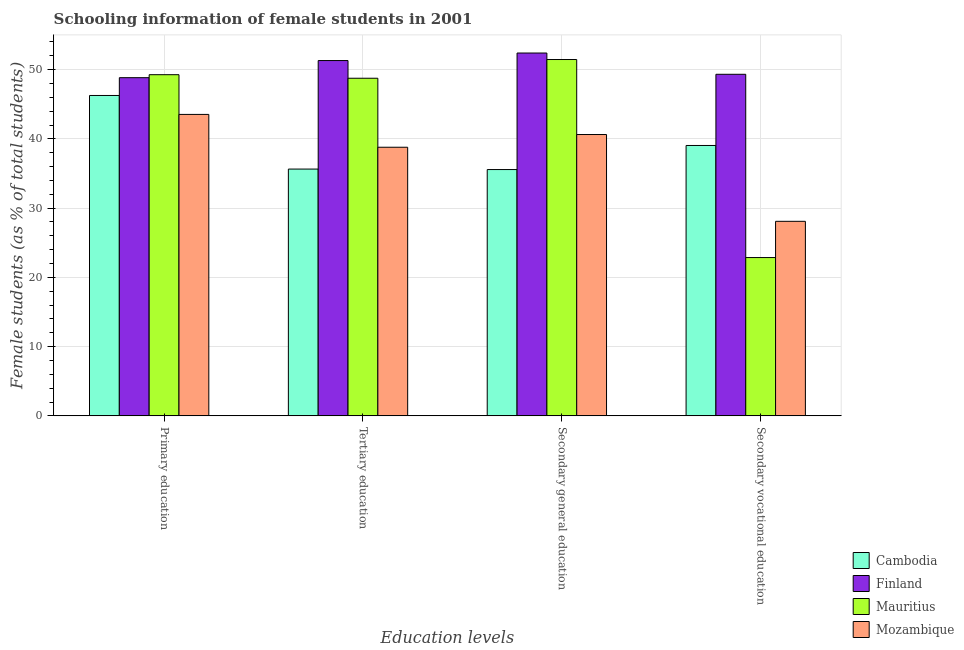How many different coloured bars are there?
Your answer should be very brief. 4. How many groups of bars are there?
Offer a very short reply. 4. Are the number of bars per tick equal to the number of legend labels?
Provide a succinct answer. Yes. Are the number of bars on each tick of the X-axis equal?
Give a very brief answer. Yes. How many bars are there on the 2nd tick from the left?
Your answer should be very brief. 4. How many bars are there on the 4th tick from the right?
Keep it short and to the point. 4. What is the label of the 4th group of bars from the left?
Keep it short and to the point. Secondary vocational education. What is the percentage of female students in secondary vocational education in Finland?
Give a very brief answer. 49.33. Across all countries, what is the maximum percentage of female students in secondary education?
Make the answer very short. 52.41. Across all countries, what is the minimum percentage of female students in tertiary education?
Make the answer very short. 35.64. In which country was the percentage of female students in primary education maximum?
Offer a very short reply. Mauritius. In which country was the percentage of female students in primary education minimum?
Provide a succinct answer. Mozambique. What is the total percentage of female students in secondary education in the graph?
Give a very brief answer. 180.08. What is the difference between the percentage of female students in primary education in Mauritius and that in Finland?
Offer a terse response. 0.43. What is the difference between the percentage of female students in secondary vocational education in Finland and the percentage of female students in primary education in Mauritius?
Your response must be concise. 0.06. What is the average percentage of female students in secondary vocational education per country?
Offer a terse response. 34.84. What is the difference between the percentage of female students in tertiary education and percentage of female students in secondary vocational education in Cambodia?
Your answer should be very brief. -3.41. What is the ratio of the percentage of female students in secondary vocational education in Mozambique to that in Cambodia?
Keep it short and to the point. 0.72. Is the difference between the percentage of female students in primary education in Finland and Mozambique greater than the difference between the percentage of female students in tertiary education in Finland and Mozambique?
Your answer should be very brief. No. What is the difference between the highest and the second highest percentage of female students in secondary vocational education?
Your answer should be very brief. 10.28. What is the difference between the highest and the lowest percentage of female students in primary education?
Give a very brief answer. 5.74. In how many countries, is the percentage of female students in secondary education greater than the average percentage of female students in secondary education taken over all countries?
Keep it short and to the point. 2. Is the sum of the percentage of female students in secondary vocational education in Finland and Mozambique greater than the maximum percentage of female students in primary education across all countries?
Offer a terse response. Yes. What does the 4th bar from the left in Tertiary education represents?
Offer a very short reply. Mozambique. What does the 4th bar from the right in Secondary general education represents?
Ensure brevity in your answer.  Cambodia. Are all the bars in the graph horizontal?
Keep it short and to the point. No. What is the difference between two consecutive major ticks on the Y-axis?
Offer a terse response. 10. Are the values on the major ticks of Y-axis written in scientific E-notation?
Provide a succinct answer. No. Does the graph contain any zero values?
Your answer should be compact. No. Does the graph contain grids?
Provide a succinct answer. Yes. How many legend labels are there?
Your response must be concise. 4. How are the legend labels stacked?
Offer a very short reply. Vertical. What is the title of the graph?
Your answer should be compact. Schooling information of female students in 2001. Does "Chad" appear as one of the legend labels in the graph?
Your answer should be compact. No. What is the label or title of the X-axis?
Your response must be concise. Education levels. What is the label or title of the Y-axis?
Provide a succinct answer. Female students (as % of total students). What is the Female students (as % of total students) of Cambodia in Primary education?
Offer a terse response. 46.27. What is the Female students (as % of total students) in Finland in Primary education?
Make the answer very short. 48.84. What is the Female students (as % of total students) in Mauritius in Primary education?
Provide a succinct answer. 49.28. What is the Female students (as % of total students) of Mozambique in Primary education?
Make the answer very short. 43.54. What is the Female students (as % of total students) in Cambodia in Tertiary education?
Make the answer very short. 35.64. What is the Female students (as % of total students) in Finland in Tertiary education?
Offer a terse response. 51.32. What is the Female students (as % of total students) of Mauritius in Tertiary education?
Provide a succinct answer. 48.76. What is the Female students (as % of total students) in Mozambique in Tertiary education?
Offer a very short reply. 38.8. What is the Female students (as % of total students) of Cambodia in Secondary general education?
Your response must be concise. 35.57. What is the Female students (as % of total students) in Finland in Secondary general education?
Offer a terse response. 52.41. What is the Female students (as % of total students) in Mauritius in Secondary general education?
Provide a short and direct response. 51.47. What is the Female students (as % of total students) in Mozambique in Secondary general education?
Offer a terse response. 40.63. What is the Female students (as % of total students) of Cambodia in Secondary vocational education?
Provide a short and direct response. 39.05. What is the Female students (as % of total students) in Finland in Secondary vocational education?
Ensure brevity in your answer.  49.33. What is the Female students (as % of total students) in Mauritius in Secondary vocational education?
Your answer should be very brief. 22.86. What is the Female students (as % of total students) in Mozambique in Secondary vocational education?
Your response must be concise. 28.1. Across all Education levels, what is the maximum Female students (as % of total students) in Cambodia?
Your response must be concise. 46.27. Across all Education levels, what is the maximum Female students (as % of total students) of Finland?
Your answer should be compact. 52.41. Across all Education levels, what is the maximum Female students (as % of total students) of Mauritius?
Ensure brevity in your answer.  51.47. Across all Education levels, what is the maximum Female students (as % of total students) of Mozambique?
Ensure brevity in your answer.  43.54. Across all Education levels, what is the minimum Female students (as % of total students) of Cambodia?
Provide a short and direct response. 35.57. Across all Education levels, what is the minimum Female students (as % of total students) of Finland?
Keep it short and to the point. 48.84. Across all Education levels, what is the minimum Female students (as % of total students) in Mauritius?
Give a very brief answer. 22.86. Across all Education levels, what is the minimum Female students (as % of total students) in Mozambique?
Offer a terse response. 28.1. What is the total Female students (as % of total students) of Cambodia in the graph?
Offer a very short reply. 156.54. What is the total Female students (as % of total students) in Finland in the graph?
Keep it short and to the point. 201.9. What is the total Female students (as % of total students) in Mauritius in the graph?
Keep it short and to the point. 172.37. What is the total Female students (as % of total students) in Mozambique in the graph?
Make the answer very short. 151.07. What is the difference between the Female students (as % of total students) of Cambodia in Primary education and that in Tertiary education?
Your response must be concise. 10.63. What is the difference between the Female students (as % of total students) of Finland in Primary education and that in Tertiary education?
Your answer should be very brief. -2.47. What is the difference between the Female students (as % of total students) of Mauritius in Primary education and that in Tertiary education?
Provide a short and direct response. 0.51. What is the difference between the Female students (as % of total students) in Mozambique in Primary education and that in Tertiary education?
Your answer should be very brief. 4.74. What is the difference between the Female students (as % of total students) in Cambodia in Primary education and that in Secondary general education?
Offer a very short reply. 10.7. What is the difference between the Female students (as % of total students) of Finland in Primary education and that in Secondary general education?
Offer a terse response. -3.56. What is the difference between the Female students (as % of total students) in Mauritius in Primary education and that in Secondary general education?
Keep it short and to the point. -2.19. What is the difference between the Female students (as % of total students) of Mozambique in Primary education and that in Secondary general education?
Give a very brief answer. 2.91. What is the difference between the Female students (as % of total students) in Cambodia in Primary education and that in Secondary vocational education?
Provide a succinct answer. 7.22. What is the difference between the Female students (as % of total students) of Finland in Primary education and that in Secondary vocational education?
Offer a terse response. -0.49. What is the difference between the Female students (as % of total students) of Mauritius in Primary education and that in Secondary vocational education?
Offer a terse response. 26.41. What is the difference between the Female students (as % of total students) in Mozambique in Primary education and that in Secondary vocational education?
Provide a short and direct response. 15.44. What is the difference between the Female students (as % of total students) in Cambodia in Tertiary education and that in Secondary general education?
Keep it short and to the point. 0.07. What is the difference between the Female students (as % of total students) of Finland in Tertiary education and that in Secondary general education?
Keep it short and to the point. -1.09. What is the difference between the Female students (as % of total students) in Mauritius in Tertiary education and that in Secondary general education?
Ensure brevity in your answer.  -2.7. What is the difference between the Female students (as % of total students) of Mozambique in Tertiary education and that in Secondary general education?
Ensure brevity in your answer.  -1.84. What is the difference between the Female students (as % of total students) in Cambodia in Tertiary education and that in Secondary vocational education?
Provide a short and direct response. -3.41. What is the difference between the Female students (as % of total students) of Finland in Tertiary education and that in Secondary vocational education?
Make the answer very short. 1.98. What is the difference between the Female students (as % of total students) in Mauritius in Tertiary education and that in Secondary vocational education?
Your answer should be compact. 25.9. What is the difference between the Female students (as % of total students) in Mozambique in Tertiary education and that in Secondary vocational education?
Ensure brevity in your answer.  10.7. What is the difference between the Female students (as % of total students) of Cambodia in Secondary general education and that in Secondary vocational education?
Offer a terse response. -3.48. What is the difference between the Female students (as % of total students) of Finland in Secondary general education and that in Secondary vocational education?
Make the answer very short. 3.07. What is the difference between the Female students (as % of total students) of Mauritius in Secondary general education and that in Secondary vocational education?
Your answer should be very brief. 28.6. What is the difference between the Female students (as % of total students) in Mozambique in Secondary general education and that in Secondary vocational education?
Provide a short and direct response. 12.53. What is the difference between the Female students (as % of total students) of Cambodia in Primary education and the Female students (as % of total students) of Finland in Tertiary education?
Your answer should be very brief. -5.04. What is the difference between the Female students (as % of total students) of Cambodia in Primary education and the Female students (as % of total students) of Mauritius in Tertiary education?
Keep it short and to the point. -2.49. What is the difference between the Female students (as % of total students) of Cambodia in Primary education and the Female students (as % of total students) of Mozambique in Tertiary education?
Ensure brevity in your answer.  7.48. What is the difference between the Female students (as % of total students) in Finland in Primary education and the Female students (as % of total students) in Mauritius in Tertiary education?
Provide a short and direct response. 0.08. What is the difference between the Female students (as % of total students) in Finland in Primary education and the Female students (as % of total students) in Mozambique in Tertiary education?
Provide a short and direct response. 10.05. What is the difference between the Female students (as % of total students) in Mauritius in Primary education and the Female students (as % of total students) in Mozambique in Tertiary education?
Keep it short and to the point. 10.48. What is the difference between the Female students (as % of total students) of Cambodia in Primary education and the Female students (as % of total students) of Finland in Secondary general education?
Provide a short and direct response. -6.13. What is the difference between the Female students (as % of total students) in Cambodia in Primary education and the Female students (as % of total students) in Mauritius in Secondary general education?
Make the answer very short. -5.19. What is the difference between the Female students (as % of total students) in Cambodia in Primary education and the Female students (as % of total students) in Mozambique in Secondary general education?
Make the answer very short. 5.64. What is the difference between the Female students (as % of total students) in Finland in Primary education and the Female students (as % of total students) in Mauritius in Secondary general education?
Offer a terse response. -2.62. What is the difference between the Female students (as % of total students) in Finland in Primary education and the Female students (as % of total students) in Mozambique in Secondary general education?
Provide a succinct answer. 8.21. What is the difference between the Female students (as % of total students) of Mauritius in Primary education and the Female students (as % of total students) of Mozambique in Secondary general education?
Make the answer very short. 8.64. What is the difference between the Female students (as % of total students) of Cambodia in Primary education and the Female students (as % of total students) of Finland in Secondary vocational education?
Offer a very short reply. -3.06. What is the difference between the Female students (as % of total students) of Cambodia in Primary education and the Female students (as % of total students) of Mauritius in Secondary vocational education?
Offer a terse response. 23.41. What is the difference between the Female students (as % of total students) of Cambodia in Primary education and the Female students (as % of total students) of Mozambique in Secondary vocational education?
Offer a terse response. 18.17. What is the difference between the Female students (as % of total students) of Finland in Primary education and the Female students (as % of total students) of Mauritius in Secondary vocational education?
Give a very brief answer. 25.98. What is the difference between the Female students (as % of total students) of Finland in Primary education and the Female students (as % of total students) of Mozambique in Secondary vocational education?
Provide a short and direct response. 20.75. What is the difference between the Female students (as % of total students) of Mauritius in Primary education and the Female students (as % of total students) of Mozambique in Secondary vocational education?
Your response must be concise. 21.18. What is the difference between the Female students (as % of total students) of Cambodia in Tertiary education and the Female students (as % of total students) of Finland in Secondary general education?
Give a very brief answer. -16.76. What is the difference between the Female students (as % of total students) of Cambodia in Tertiary education and the Female students (as % of total students) of Mauritius in Secondary general education?
Ensure brevity in your answer.  -15.82. What is the difference between the Female students (as % of total students) of Cambodia in Tertiary education and the Female students (as % of total students) of Mozambique in Secondary general education?
Your answer should be compact. -4.99. What is the difference between the Female students (as % of total students) of Finland in Tertiary education and the Female students (as % of total students) of Mauritius in Secondary general education?
Keep it short and to the point. -0.15. What is the difference between the Female students (as % of total students) of Finland in Tertiary education and the Female students (as % of total students) of Mozambique in Secondary general education?
Offer a very short reply. 10.68. What is the difference between the Female students (as % of total students) of Mauritius in Tertiary education and the Female students (as % of total students) of Mozambique in Secondary general education?
Your response must be concise. 8.13. What is the difference between the Female students (as % of total students) in Cambodia in Tertiary education and the Female students (as % of total students) in Finland in Secondary vocational education?
Make the answer very short. -13.69. What is the difference between the Female students (as % of total students) in Cambodia in Tertiary education and the Female students (as % of total students) in Mauritius in Secondary vocational education?
Ensure brevity in your answer.  12.78. What is the difference between the Female students (as % of total students) in Cambodia in Tertiary education and the Female students (as % of total students) in Mozambique in Secondary vocational education?
Offer a terse response. 7.54. What is the difference between the Female students (as % of total students) in Finland in Tertiary education and the Female students (as % of total students) in Mauritius in Secondary vocational education?
Keep it short and to the point. 28.45. What is the difference between the Female students (as % of total students) in Finland in Tertiary education and the Female students (as % of total students) in Mozambique in Secondary vocational education?
Your answer should be very brief. 23.22. What is the difference between the Female students (as % of total students) in Mauritius in Tertiary education and the Female students (as % of total students) in Mozambique in Secondary vocational education?
Make the answer very short. 20.66. What is the difference between the Female students (as % of total students) in Cambodia in Secondary general education and the Female students (as % of total students) in Finland in Secondary vocational education?
Give a very brief answer. -13.76. What is the difference between the Female students (as % of total students) in Cambodia in Secondary general education and the Female students (as % of total students) in Mauritius in Secondary vocational education?
Offer a terse response. 12.71. What is the difference between the Female students (as % of total students) in Cambodia in Secondary general education and the Female students (as % of total students) in Mozambique in Secondary vocational education?
Provide a succinct answer. 7.48. What is the difference between the Female students (as % of total students) of Finland in Secondary general education and the Female students (as % of total students) of Mauritius in Secondary vocational education?
Offer a very short reply. 29.54. What is the difference between the Female students (as % of total students) in Finland in Secondary general education and the Female students (as % of total students) in Mozambique in Secondary vocational education?
Offer a very short reply. 24.31. What is the difference between the Female students (as % of total students) of Mauritius in Secondary general education and the Female students (as % of total students) of Mozambique in Secondary vocational education?
Provide a succinct answer. 23.37. What is the average Female students (as % of total students) in Cambodia per Education levels?
Give a very brief answer. 39.14. What is the average Female students (as % of total students) of Finland per Education levels?
Make the answer very short. 50.47. What is the average Female students (as % of total students) in Mauritius per Education levels?
Offer a very short reply. 43.09. What is the average Female students (as % of total students) in Mozambique per Education levels?
Your response must be concise. 37.77. What is the difference between the Female students (as % of total students) of Cambodia and Female students (as % of total students) of Finland in Primary education?
Provide a short and direct response. -2.57. What is the difference between the Female students (as % of total students) in Cambodia and Female students (as % of total students) in Mauritius in Primary education?
Keep it short and to the point. -3. What is the difference between the Female students (as % of total students) in Cambodia and Female students (as % of total students) in Mozambique in Primary education?
Your answer should be compact. 2.73. What is the difference between the Female students (as % of total students) of Finland and Female students (as % of total students) of Mauritius in Primary education?
Provide a succinct answer. -0.43. What is the difference between the Female students (as % of total students) of Finland and Female students (as % of total students) of Mozambique in Primary education?
Provide a short and direct response. 5.31. What is the difference between the Female students (as % of total students) in Mauritius and Female students (as % of total students) in Mozambique in Primary education?
Your response must be concise. 5.74. What is the difference between the Female students (as % of total students) of Cambodia and Female students (as % of total students) of Finland in Tertiary education?
Provide a succinct answer. -15.67. What is the difference between the Female students (as % of total students) of Cambodia and Female students (as % of total students) of Mauritius in Tertiary education?
Provide a short and direct response. -13.12. What is the difference between the Female students (as % of total students) in Cambodia and Female students (as % of total students) in Mozambique in Tertiary education?
Your response must be concise. -3.15. What is the difference between the Female students (as % of total students) in Finland and Female students (as % of total students) in Mauritius in Tertiary education?
Ensure brevity in your answer.  2.56. What is the difference between the Female students (as % of total students) in Finland and Female students (as % of total students) in Mozambique in Tertiary education?
Your response must be concise. 12.52. What is the difference between the Female students (as % of total students) in Mauritius and Female students (as % of total students) in Mozambique in Tertiary education?
Your answer should be very brief. 9.96. What is the difference between the Female students (as % of total students) in Cambodia and Female students (as % of total students) in Finland in Secondary general education?
Your response must be concise. -16.83. What is the difference between the Female students (as % of total students) of Cambodia and Female students (as % of total students) of Mauritius in Secondary general education?
Make the answer very short. -15.89. What is the difference between the Female students (as % of total students) of Cambodia and Female students (as % of total students) of Mozambique in Secondary general education?
Your answer should be very brief. -5.06. What is the difference between the Female students (as % of total students) in Finland and Female students (as % of total students) in Mauritius in Secondary general education?
Keep it short and to the point. 0.94. What is the difference between the Female students (as % of total students) in Finland and Female students (as % of total students) in Mozambique in Secondary general education?
Make the answer very short. 11.77. What is the difference between the Female students (as % of total students) of Mauritius and Female students (as % of total students) of Mozambique in Secondary general education?
Your answer should be compact. 10.83. What is the difference between the Female students (as % of total students) of Cambodia and Female students (as % of total students) of Finland in Secondary vocational education?
Give a very brief answer. -10.28. What is the difference between the Female students (as % of total students) of Cambodia and Female students (as % of total students) of Mauritius in Secondary vocational education?
Make the answer very short. 16.19. What is the difference between the Female students (as % of total students) of Cambodia and Female students (as % of total students) of Mozambique in Secondary vocational education?
Your answer should be very brief. 10.95. What is the difference between the Female students (as % of total students) of Finland and Female students (as % of total students) of Mauritius in Secondary vocational education?
Your answer should be compact. 26.47. What is the difference between the Female students (as % of total students) of Finland and Female students (as % of total students) of Mozambique in Secondary vocational education?
Offer a terse response. 21.23. What is the difference between the Female students (as % of total students) of Mauritius and Female students (as % of total students) of Mozambique in Secondary vocational education?
Your response must be concise. -5.23. What is the ratio of the Female students (as % of total students) of Cambodia in Primary education to that in Tertiary education?
Ensure brevity in your answer.  1.3. What is the ratio of the Female students (as % of total students) of Finland in Primary education to that in Tertiary education?
Your answer should be very brief. 0.95. What is the ratio of the Female students (as % of total students) of Mauritius in Primary education to that in Tertiary education?
Ensure brevity in your answer.  1.01. What is the ratio of the Female students (as % of total students) in Mozambique in Primary education to that in Tertiary education?
Offer a very short reply. 1.12. What is the ratio of the Female students (as % of total students) in Cambodia in Primary education to that in Secondary general education?
Your answer should be very brief. 1.3. What is the ratio of the Female students (as % of total students) in Finland in Primary education to that in Secondary general education?
Your response must be concise. 0.93. What is the ratio of the Female students (as % of total students) of Mauritius in Primary education to that in Secondary general education?
Your answer should be compact. 0.96. What is the ratio of the Female students (as % of total students) in Mozambique in Primary education to that in Secondary general education?
Make the answer very short. 1.07. What is the ratio of the Female students (as % of total students) of Cambodia in Primary education to that in Secondary vocational education?
Provide a short and direct response. 1.18. What is the ratio of the Female students (as % of total students) of Mauritius in Primary education to that in Secondary vocational education?
Make the answer very short. 2.16. What is the ratio of the Female students (as % of total students) in Mozambique in Primary education to that in Secondary vocational education?
Ensure brevity in your answer.  1.55. What is the ratio of the Female students (as % of total students) of Cambodia in Tertiary education to that in Secondary general education?
Your answer should be very brief. 1. What is the ratio of the Female students (as % of total students) in Finland in Tertiary education to that in Secondary general education?
Ensure brevity in your answer.  0.98. What is the ratio of the Female students (as % of total students) of Mauritius in Tertiary education to that in Secondary general education?
Keep it short and to the point. 0.95. What is the ratio of the Female students (as % of total students) of Mozambique in Tertiary education to that in Secondary general education?
Offer a very short reply. 0.95. What is the ratio of the Female students (as % of total students) in Cambodia in Tertiary education to that in Secondary vocational education?
Your response must be concise. 0.91. What is the ratio of the Female students (as % of total students) of Finland in Tertiary education to that in Secondary vocational education?
Give a very brief answer. 1.04. What is the ratio of the Female students (as % of total students) of Mauritius in Tertiary education to that in Secondary vocational education?
Your answer should be compact. 2.13. What is the ratio of the Female students (as % of total students) of Mozambique in Tertiary education to that in Secondary vocational education?
Offer a very short reply. 1.38. What is the ratio of the Female students (as % of total students) of Cambodia in Secondary general education to that in Secondary vocational education?
Keep it short and to the point. 0.91. What is the ratio of the Female students (as % of total students) of Finland in Secondary general education to that in Secondary vocational education?
Offer a terse response. 1.06. What is the ratio of the Female students (as % of total students) in Mauritius in Secondary general education to that in Secondary vocational education?
Offer a terse response. 2.25. What is the ratio of the Female students (as % of total students) in Mozambique in Secondary general education to that in Secondary vocational education?
Ensure brevity in your answer.  1.45. What is the difference between the highest and the second highest Female students (as % of total students) in Cambodia?
Offer a terse response. 7.22. What is the difference between the highest and the second highest Female students (as % of total students) in Finland?
Offer a very short reply. 1.09. What is the difference between the highest and the second highest Female students (as % of total students) in Mauritius?
Offer a terse response. 2.19. What is the difference between the highest and the second highest Female students (as % of total students) of Mozambique?
Your answer should be compact. 2.91. What is the difference between the highest and the lowest Female students (as % of total students) in Cambodia?
Ensure brevity in your answer.  10.7. What is the difference between the highest and the lowest Female students (as % of total students) of Finland?
Keep it short and to the point. 3.56. What is the difference between the highest and the lowest Female students (as % of total students) in Mauritius?
Your response must be concise. 28.6. What is the difference between the highest and the lowest Female students (as % of total students) in Mozambique?
Your answer should be compact. 15.44. 